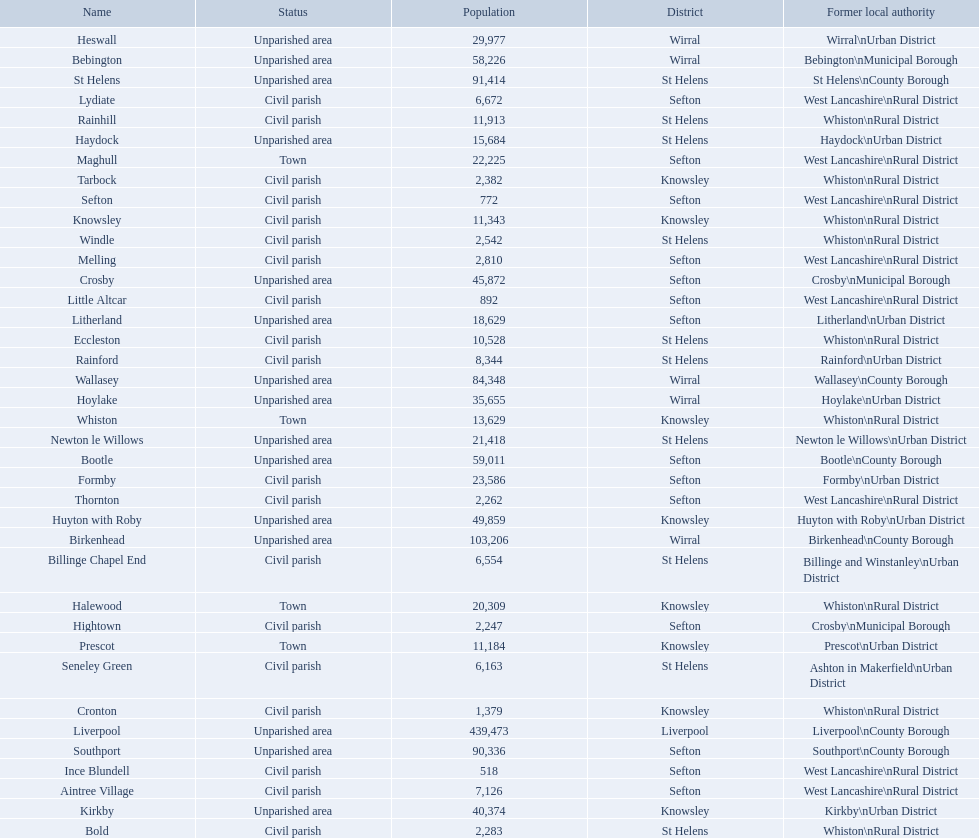What is the largest area in terms of population? Liverpool. 